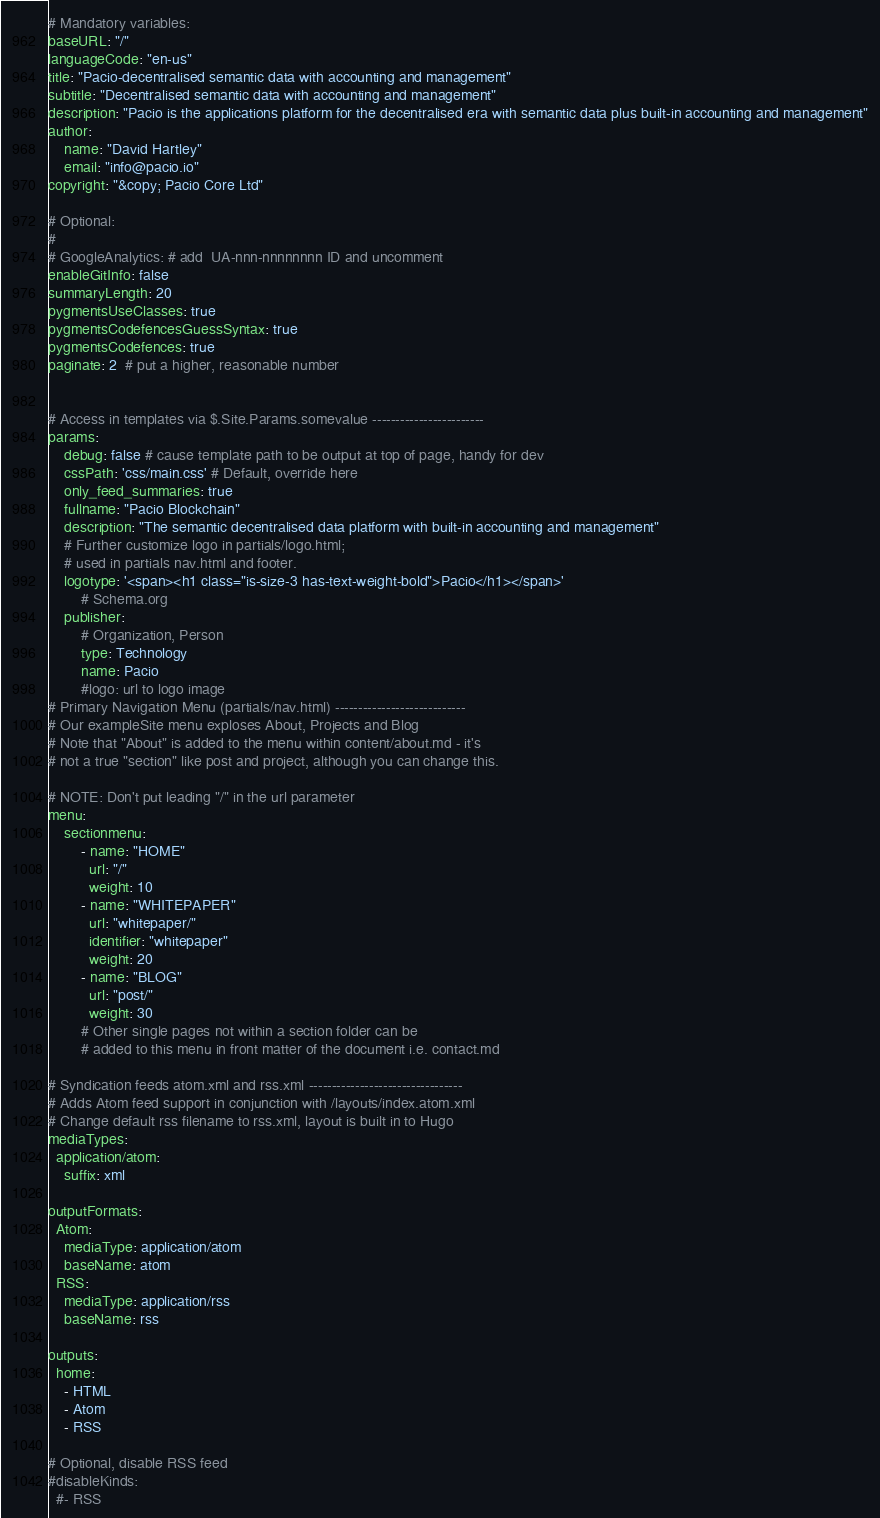Convert code to text. <code><loc_0><loc_0><loc_500><loc_500><_YAML_># Mandatory variables:
baseURL: "/"
languageCode: "en-us"
title: "Pacio-decentralised semantic data with accounting and management"
subtitle: "Decentralised semantic data with accounting and management"
description: "Pacio is the applications platform for the decentralised era with semantic data plus built-in accounting and management"
author: 
    name: "David Hartley"
    email: "info@pacio.io"
copyright: "&copy; Pacio Core Ltd"

# Optional:
#
# GoogleAnalytics: # add  UA-nnn-nnnnnnnn ID and uncomment
enableGitInfo: false
summaryLength: 20
pygmentsUseClasses: true
pygmentsCodefencesGuessSyntax: true
pygmentsCodefences: true
paginate: 2  # put a higher, reasonable number


# Access in templates via $.Site.Params.somevalue ------------------------
params: 
    debug: false # cause template path to be output at top of page, handy for dev
    cssPath: 'css/main.css' # Default, override here
    only_feed_summaries: true
    fullname: "Pacio Blockchain"
    description: "The semantic decentralised data platform with built-in accounting and management"
    # Further customize logo in partials/logo.html; 
    # used in partials nav.html and footer.
    logotype: '<span><h1 class="is-size-3 has-text-weight-bold">Pacio</h1></span>'
        # Schema.org
    publisher:
        # Organization, Person
        type: Technology
        name: Pacio 
        #logo: url to logo image
# Primary Navigation Menu (partials/nav.html) ----------------------------
# Our exampleSite menu exploses About, Projects and Blog
# Note that "About" is added to the menu within content/about.md - it's 
# not a true "section" like post and project, although you can change this.

# NOTE: Don't put leading "/" in the url parameter
menu:
    sectionmenu:
        - name: "HOME"
          url: "/"
          weight: 10
        - name: "WHITEPAPER"
          url: "whitepaper/"
          identifier: "whitepaper"
          weight: 20
        - name: "BLOG"
          url: "post/"
          weight: 30
        # Other single pages not within a section folder can be  
        # added to this menu in front matter of the document i.e. contact.md

# Syndication feeds atom.xml and rss.xml ---------------------------------
# Adds Atom feed support in conjunction with /layouts/index.atom.xml
# Change default rss filename to rss.xml, layout is built in to Hugo 
mediaTypes:
  application/atom:
    suffix: xml

outputFormats:
  Atom:
    mediaType: application/atom
    baseName: atom
  RSS:
    mediaType: application/rss
    baseName: rss

outputs:
  home:
    - HTML
    - Atom
    - RSS

# Optional, disable RSS feed
#disableKinds:
  #- RSS
</code> 